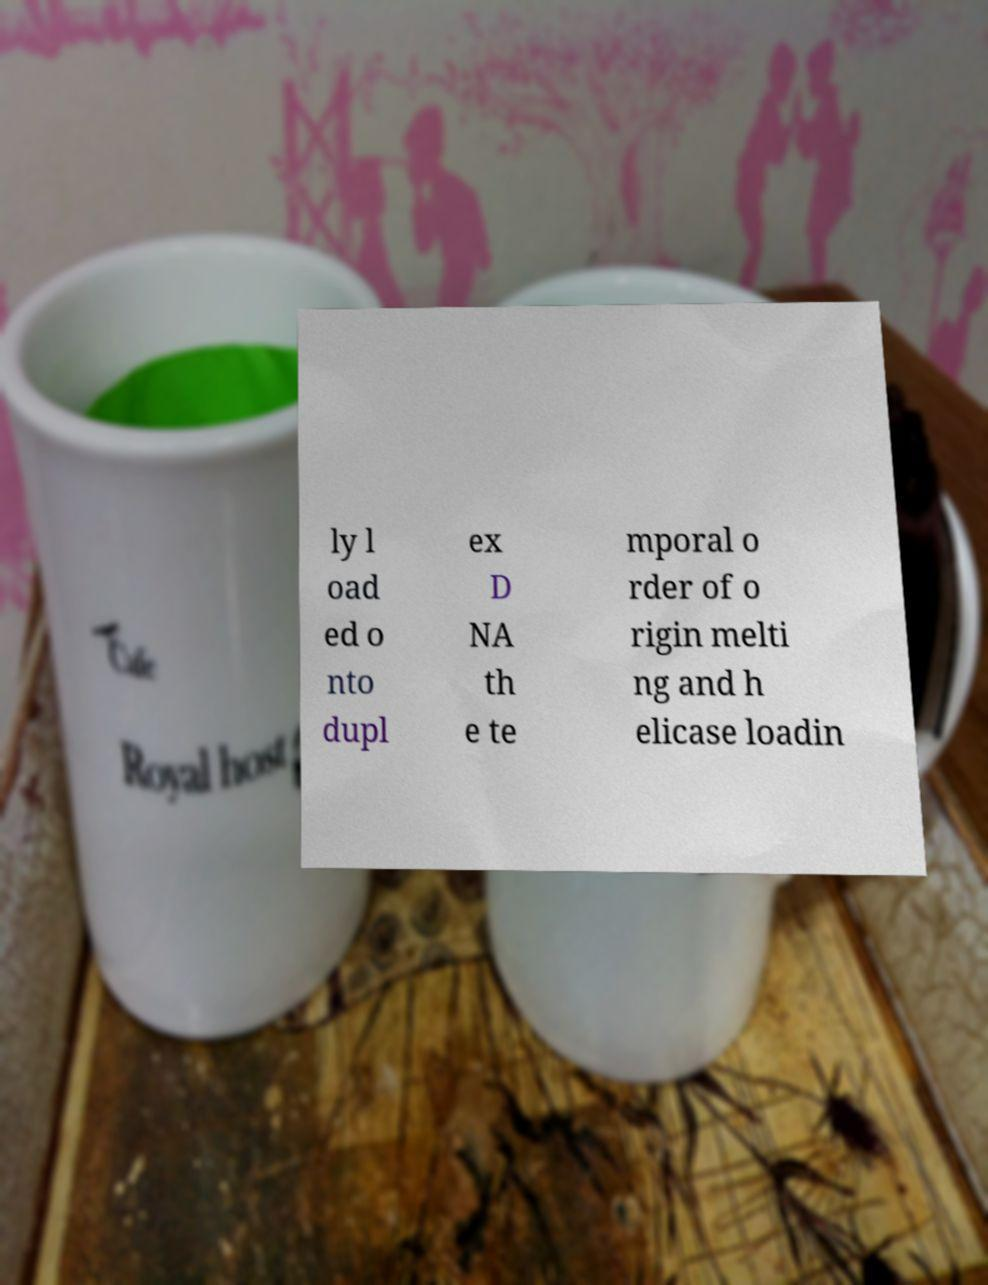There's text embedded in this image that I need extracted. Can you transcribe it verbatim? ly l oad ed o nto dupl ex D NA th e te mporal o rder of o rigin melti ng and h elicase loadin 